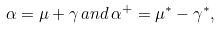Convert formula to latex. <formula><loc_0><loc_0><loc_500><loc_500>\alpha = \mu + \gamma \, a n d \, \alpha ^ { + } = \mu ^ { \ast } - \gamma ^ { \ast } ,</formula> 